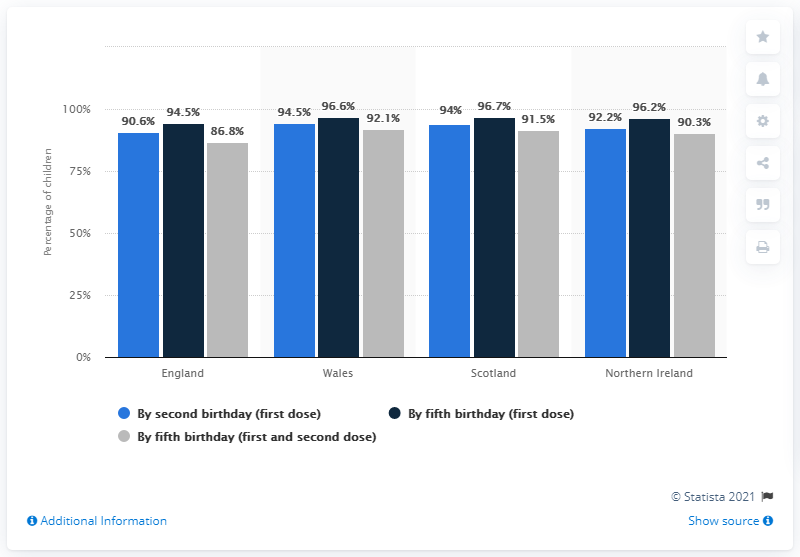Point out several critical features in this image. Wales is the country with the highest rate of vaccination by second birthday (first dose) compared to the other countries. The study found that a specific color, grey, was associated with a particular event, a fifth birthday, in both the first and second doses of a vaccine. 